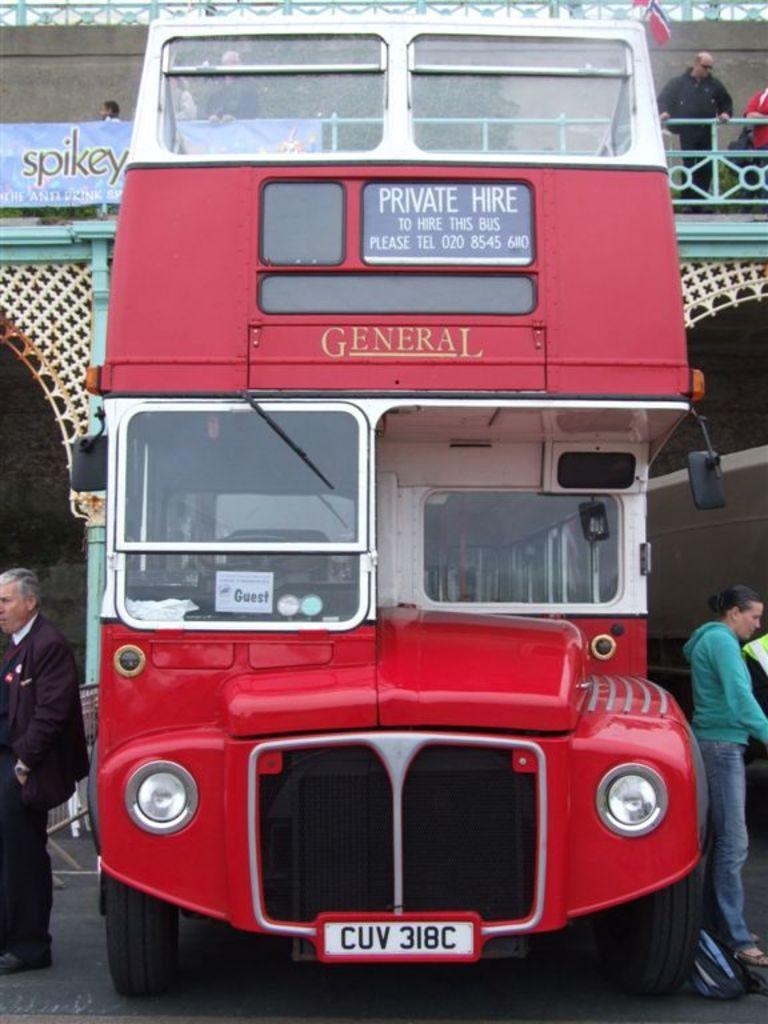In one or two sentences, can you explain what this image depicts? In the center of the image we can see bus. On the right and left side of the image we can see persons. In the background we can see building and persons. 